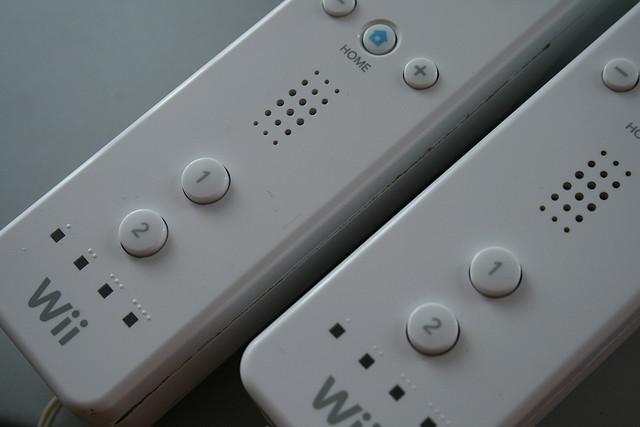Are all the holes on the remote the same size?
Quick response, please. No. What kind of remote is shown?
Write a very short answer. Wii. Who makes this control?
Be succinct. Nintendo. How many WII remotes are here?
Answer briefly. 2. 